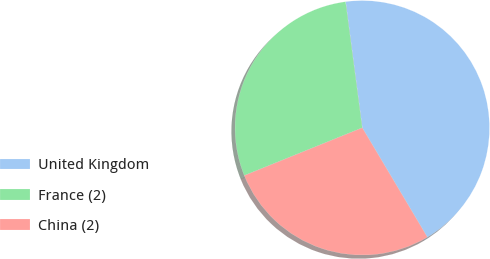<chart> <loc_0><loc_0><loc_500><loc_500><pie_chart><fcel>United Kingdom<fcel>France (2)<fcel>China (2)<nl><fcel>43.55%<fcel>29.03%<fcel>27.42%<nl></chart> 